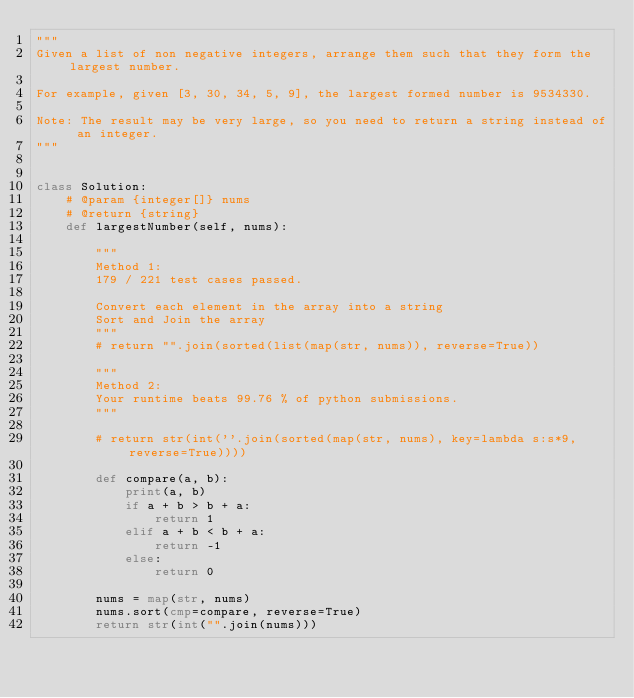<code> <loc_0><loc_0><loc_500><loc_500><_Python_>"""
Given a list of non negative integers, arrange them such that they form the largest number.

For example, given [3, 30, 34, 5, 9], the largest formed number is 9534330.

Note: The result may be very large, so you need to return a string instead of an integer.
"""


class Solution:
    # @param {integer[]} nums
    # @return {string}
    def largestNumber(self, nums):

        """
        Method 1:
        179 / 221 test cases passed.

        Convert each element in the array into a string
        Sort and Join the array
        """
        # return "".join(sorted(list(map(str, nums)), reverse=True))

        """
        Method 2:
        Your runtime beats 99.76 % of python submissions.
        """

        # return str(int(''.join(sorted(map(str, nums), key=lambda s:s*9, reverse=True))))

        def compare(a, b):
            print(a, b)
            if a + b > b + a:
                return 1
            elif a + b < b + a:
                return -1
            else:
                return 0

        nums = map(str, nums)
        nums.sort(cmp=compare, reverse=True)
        return str(int("".join(nums)))
</code> 